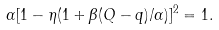<formula> <loc_0><loc_0><loc_500><loc_500>\alpha [ 1 - \eta ( 1 + \beta ( Q - q ) / \alpha ) ] ^ { 2 } = 1 .</formula> 